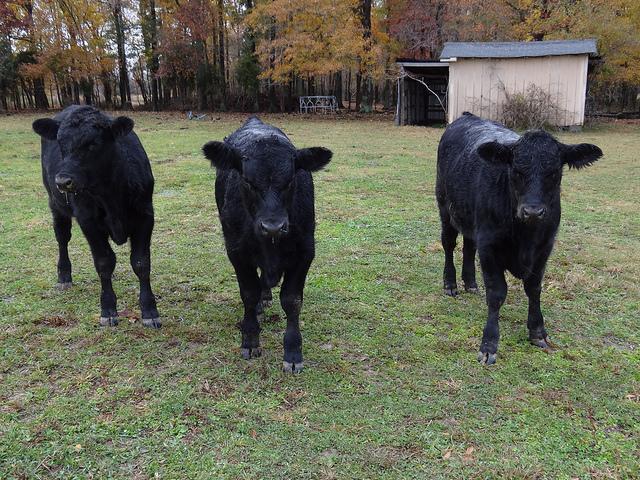How many cows are on the grass?
Give a very brief answer. 3. How many cows are facing the camera?
Give a very brief answer. 3. How many adult cows are in the picture?
Give a very brief answer. 3. How many cows can be seen?
Give a very brief answer. 3. How many people are holding umbrellas?
Give a very brief answer. 0. 